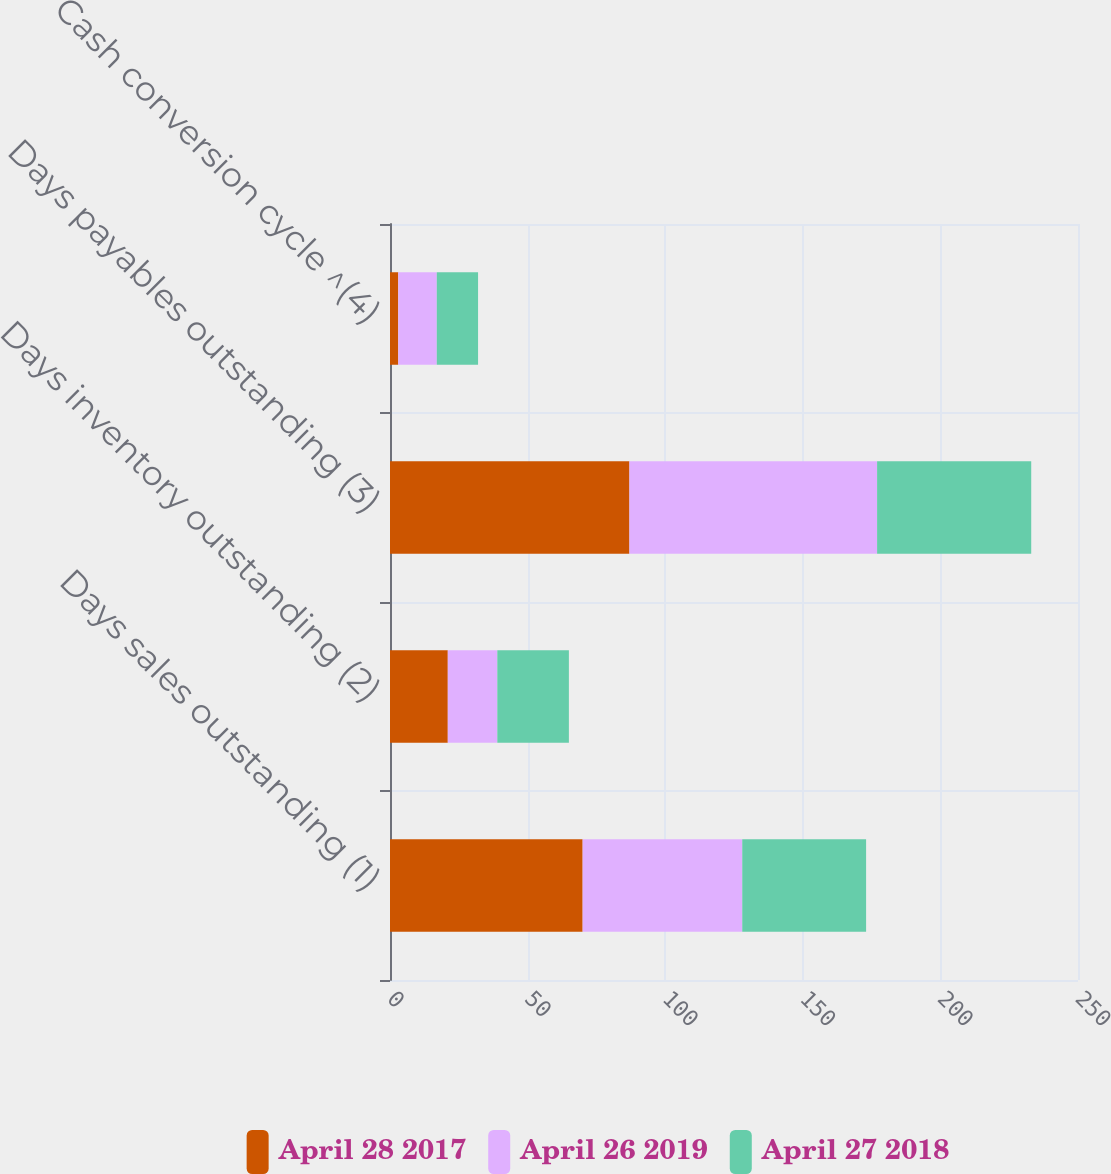<chart> <loc_0><loc_0><loc_500><loc_500><stacked_bar_chart><ecel><fcel>Days sales outstanding (1)<fcel>Days inventory outstanding (2)<fcel>Days payables outstanding (3)<fcel>Cash conversion cycle ^(4)<nl><fcel>April 28 2017<fcel>70<fcel>21<fcel>87<fcel>3<nl><fcel>April 26 2019<fcel>58<fcel>18<fcel>90<fcel>14<nl><fcel>April 27 2018<fcel>45<fcel>26<fcel>56<fcel>15<nl></chart> 